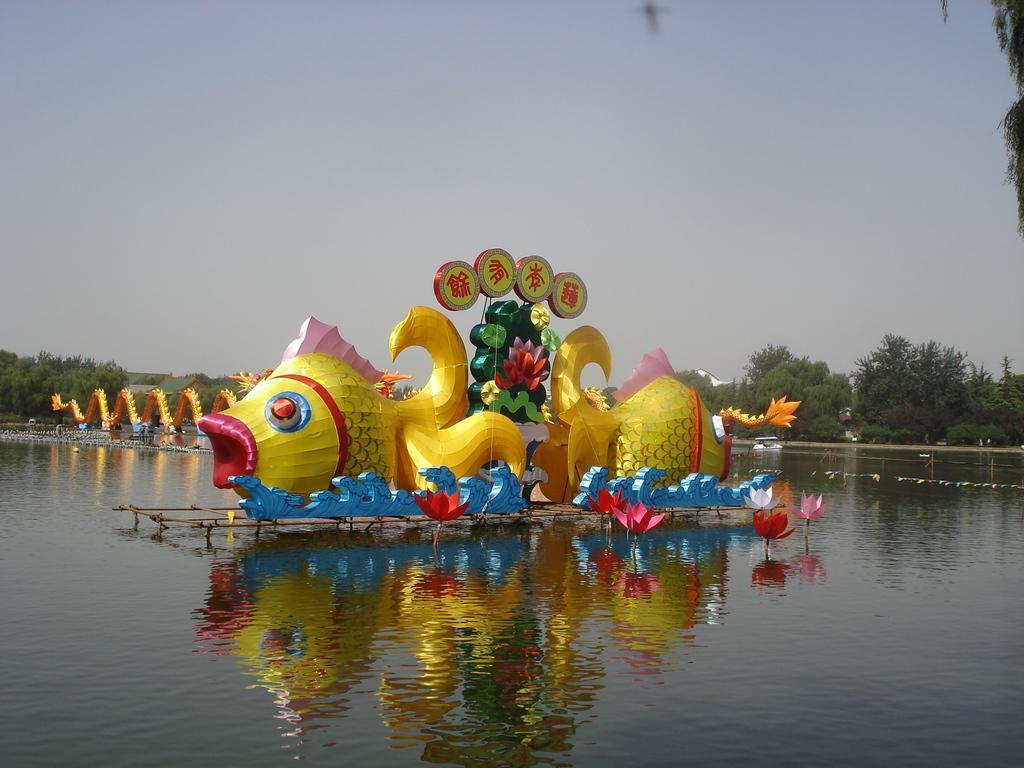Please provide a concise description of this image. This image is clicked outside. There is something like a boat in the middle. There is water at the bottom. There are trees in the middle. There is sky at the top. 